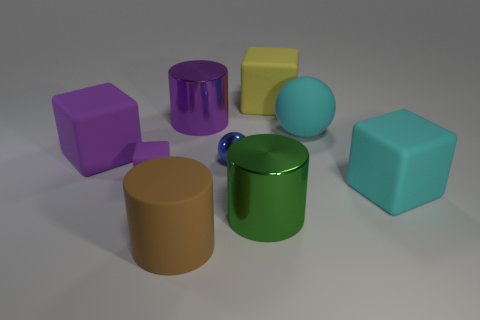What number of things are either small metallic balls or large blocks that are behind the large cyan cube?
Provide a succinct answer. 3. There is a large object that is the same shape as the small blue metal object; what is its material?
Offer a terse response. Rubber. There is a cyan object that is to the right of the cyan ball; does it have the same shape as the big green object?
Keep it short and to the point. No. Are there fewer purple rubber objects to the left of the tiny blue metal thing than tiny metal things that are behind the purple cylinder?
Provide a short and direct response. No. How many other objects are there of the same shape as the blue object?
Offer a terse response. 1. What size is the sphere left of the large cylinder that is to the right of the blue sphere on the left side of the green shiny object?
Keep it short and to the point. Small. How many cyan things are either large matte cylinders or big spheres?
Provide a short and direct response. 1. The big cyan thing that is in front of the big thing that is on the left side of the big brown cylinder is what shape?
Offer a very short reply. Cube. Do the purple thing on the right side of the brown rubber cylinder and the purple block in front of the tiny blue metallic thing have the same size?
Give a very brief answer. No. Is there a big gray thing that has the same material as the tiny block?
Your response must be concise. No. 